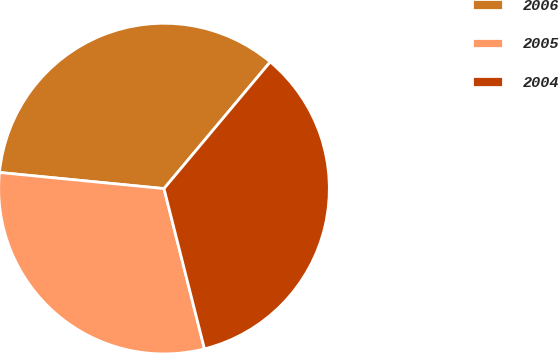Convert chart to OTSL. <chart><loc_0><loc_0><loc_500><loc_500><pie_chart><fcel>2006<fcel>2005<fcel>2004<nl><fcel>34.55%<fcel>30.49%<fcel>34.96%<nl></chart> 